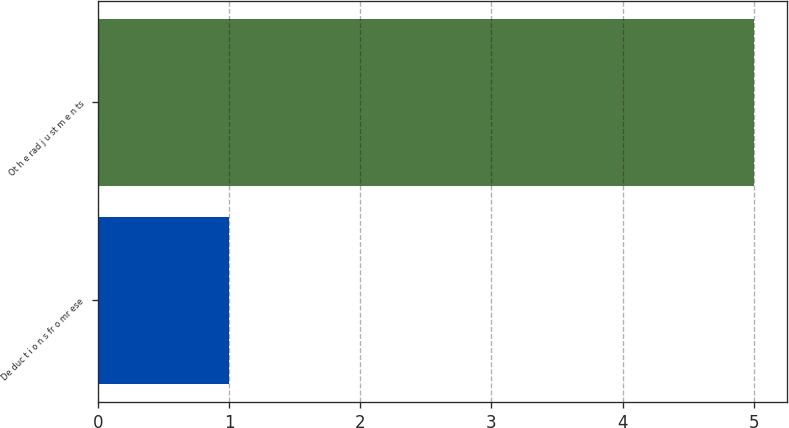Convert chart to OTSL. <chart><loc_0><loc_0><loc_500><loc_500><bar_chart><fcel>De duc t i o n s fr o mr ese<fcel>Ot h e rad j u st m e n ts<nl><fcel>1<fcel>5<nl></chart> 